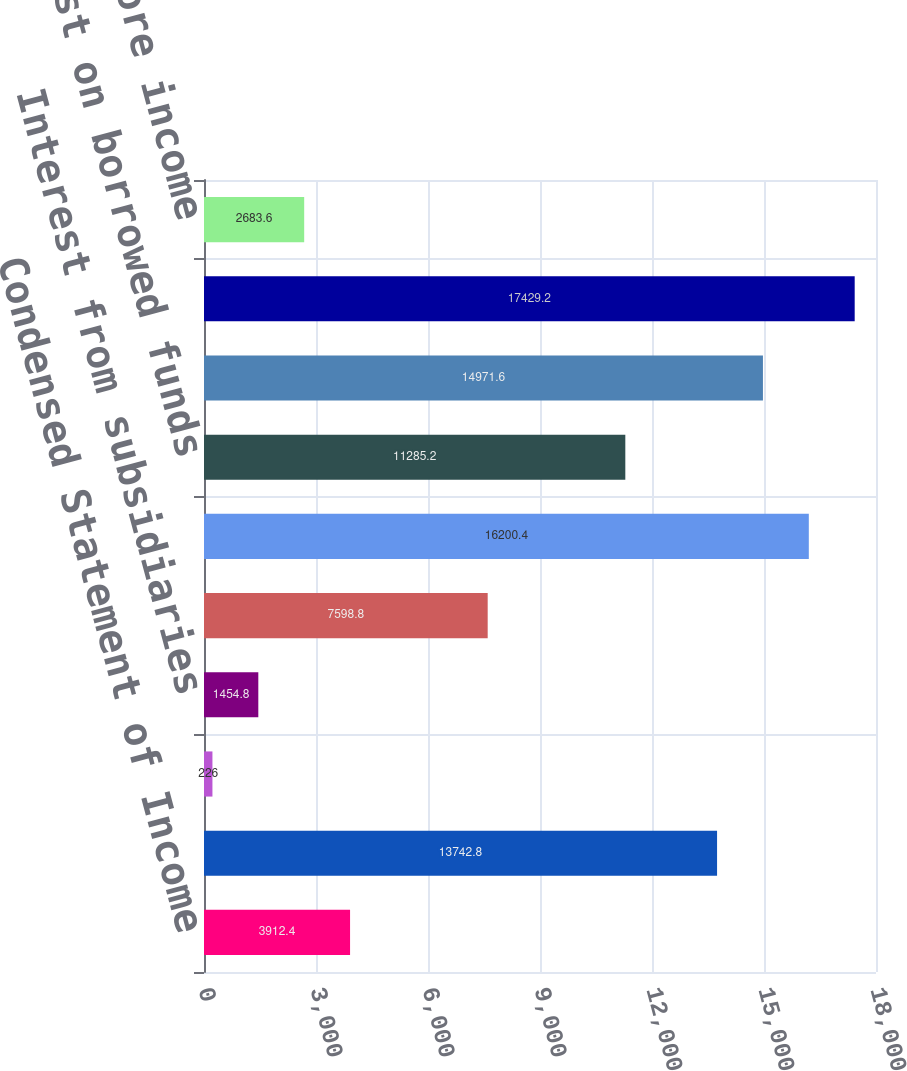Convert chart. <chart><loc_0><loc_0><loc_500><loc_500><bar_chart><fcel>Condensed Statement of Income<fcel>Bank holding companies and<fcel>Nonbank companies and related<fcel>Interest from subsidiaries<fcel>Other income (1)<fcel>Total income<fcel>Interest on borrowed funds<fcel>Noninterest expense (2)<fcel>Total expense<fcel>Income (loss) before income<nl><fcel>3912.4<fcel>13742.8<fcel>226<fcel>1454.8<fcel>7598.8<fcel>16200.4<fcel>11285.2<fcel>14971.6<fcel>17429.2<fcel>2683.6<nl></chart> 